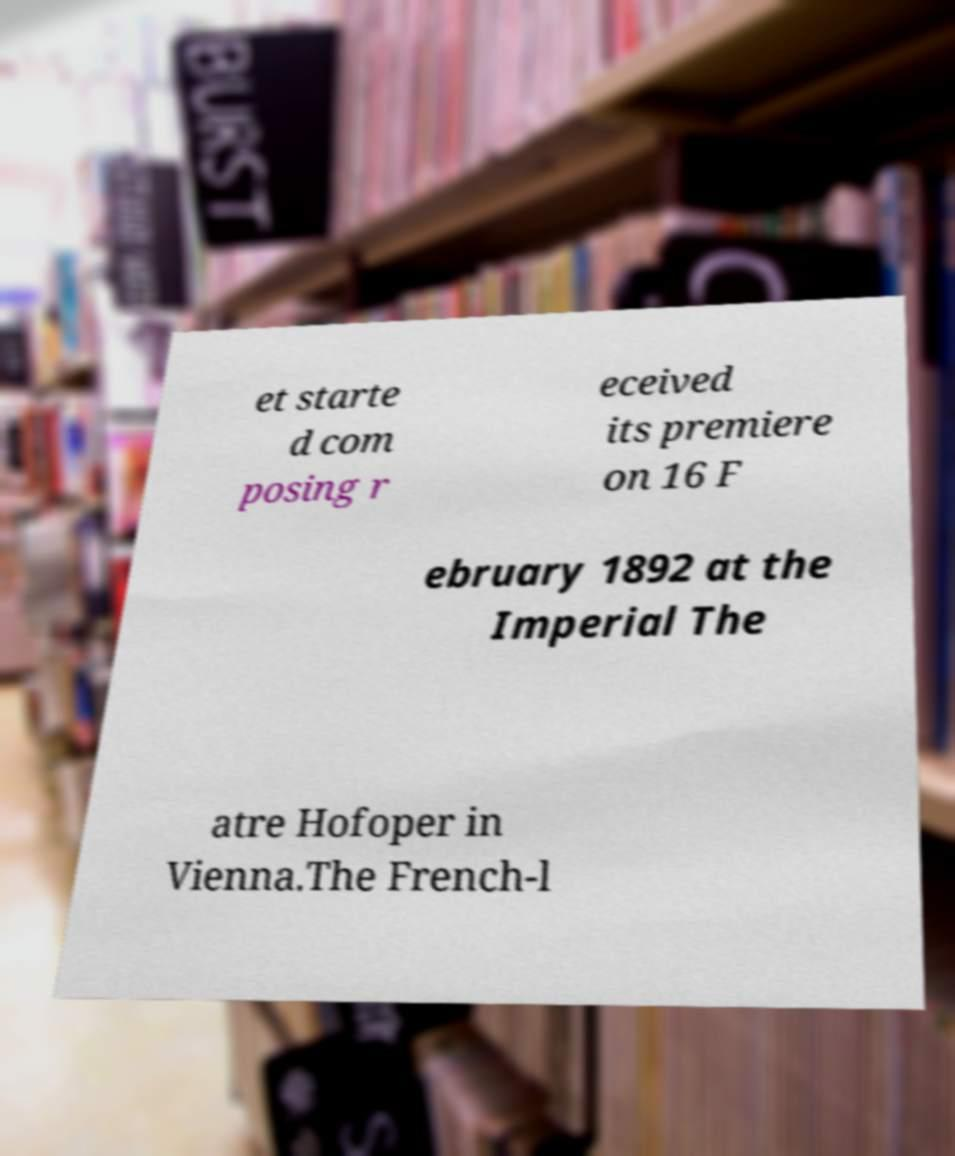There's text embedded in this image that I need extracted. Can you transcribe it verbatim? et starte d com posing r eceived its premiere on 16 F ebruary 1892 at the Imperial The atre Hofoper in Vienna.The French-l 